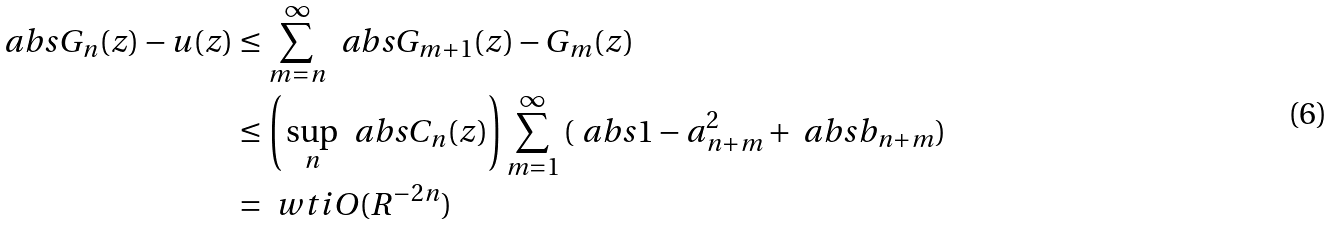Convert formula to latex. <formula><loc_0><loc_0><loc_500><loc_500>\ a b s { G _ { n } ( z ) - u ( z ) } & \leq \sum _ { m = n } ^ { \infty } \, \ a b s { G _ { m + 1 } ( z ) - G _ { m } ( z ) } \\ & \leq \left ( \, \sup _ { n } \, \ a b s { C _ { n } ( z ) } \right ) \sum _ { m = 1 } ^ { \infty } \, ( \ a b s { 1 - a _ { n + m } ^ { 2 } } + \ a b s { b _ { n + m } } ) \\ & = \ w t i O ( R ^ { - 2 n } )</formula> 